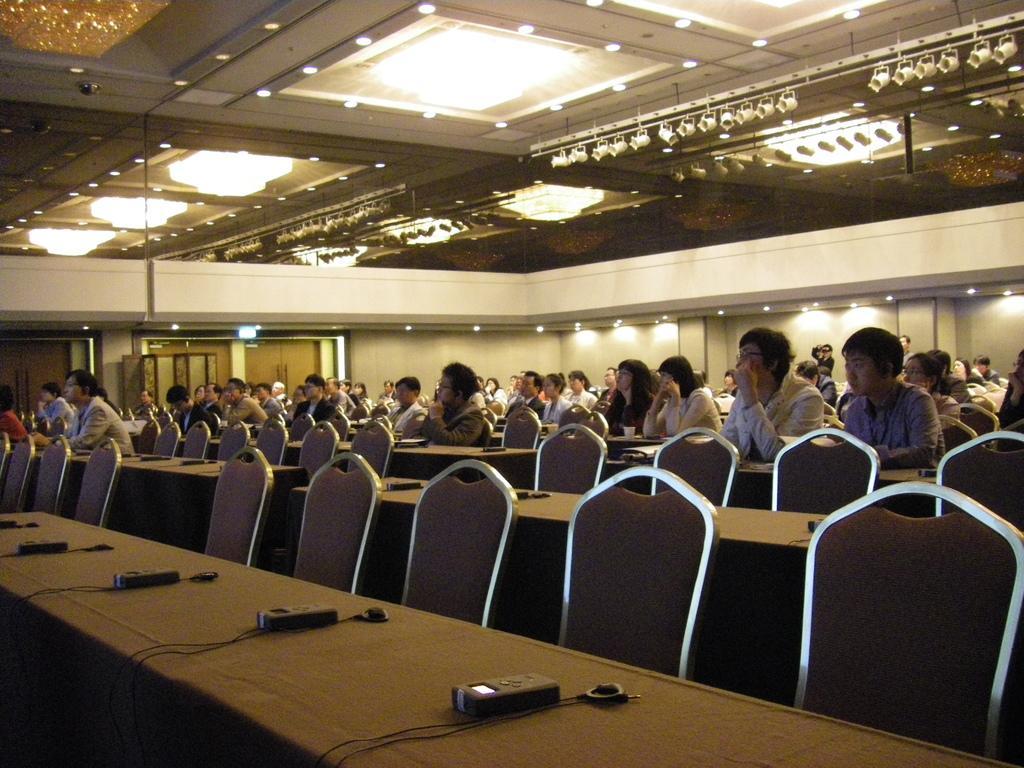Can you describe this image briefly? This is the picture of a room. In this image there are group of people sitting on the chairs. There are devices and wires on the table. There are tables and chairs. At the back there is a door. At the top there are lights. 